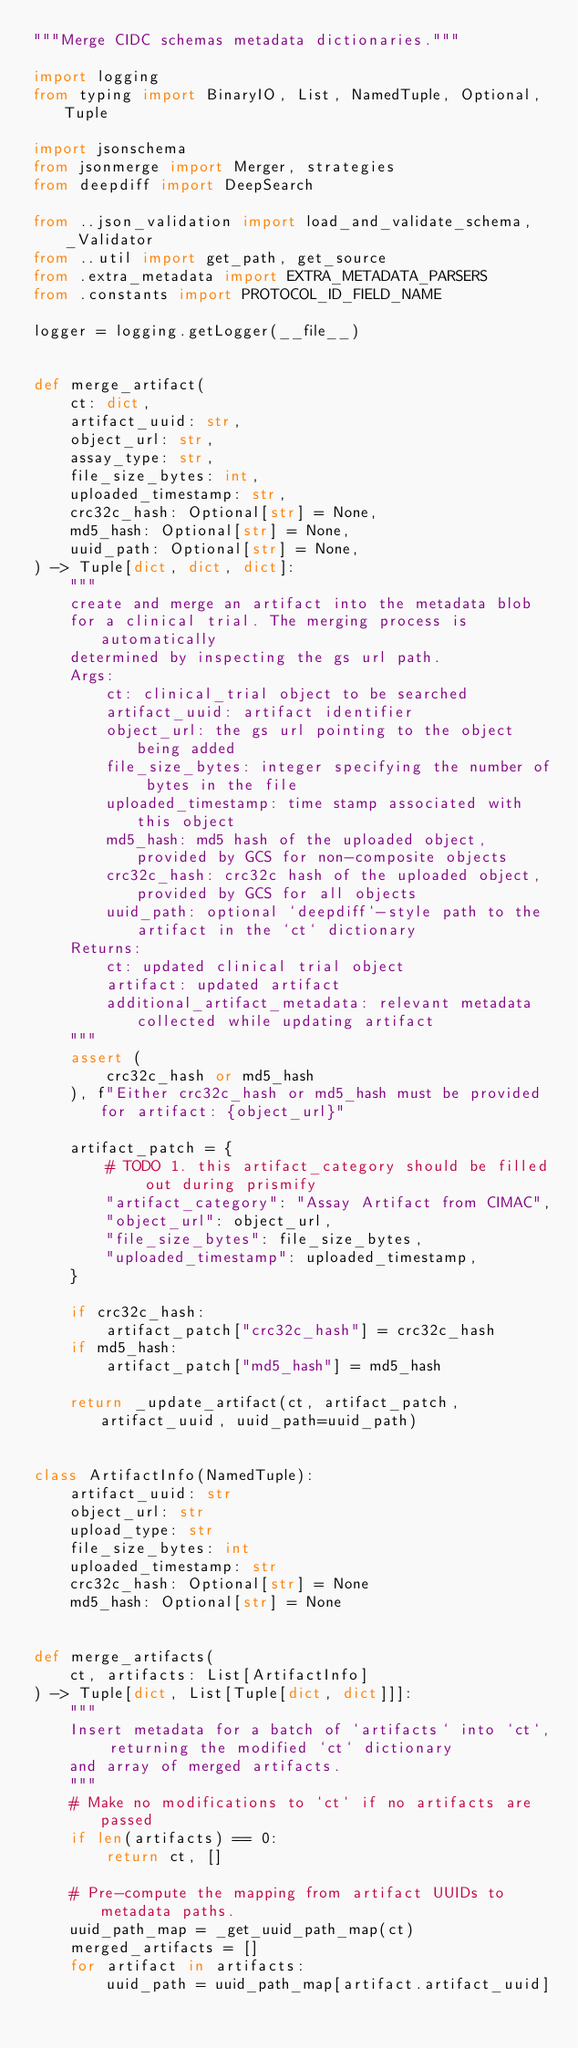<code> <loc_0><loc_0><loc_500><loc_500><_Python_>"""Merge CIDC schemas metadata dictionaries."""

import logging
from typing import BinaryIO, List, NamedTuple, Optional, Tuple

import jsonschema
from jsonmerge import Merger, strategies
from deepdiff import DeepSearch

from ..json_validation import load_and_validate_schema, _Validator
from ..util import get_path, get_source
from .extra_metadata import EXTRA_METADATA_PARSERS
from .constants import PROTOCOL_ID_FIELD_NAME

logger = logging.getLogger(__file__)


def merge_artifact(
    ct: dict,
    artifact_uuid: str,
    object_url: str,
    assay_type: str,
    file_size_bytes: int,
    uploaded_timestamp: str,
    crc32c_hash: Optional[str] = None,
    md5_hash: Optional[str] = None,
    uuid_path: Optional[str] = None,
) -> Tuple[dict, dict, dict]:
    """
    create and merge an artifact into the metadata blob
    for a clinical trial. The merging process is automatically
    determined by inspecting the gs url path.
    Args:
        ct: clinical_trial object to be searched
        artifact_uuid: artifact identifier
        object_url: the gs url pointing to the object being added
        file_size_bytes: integer specifying the number of bytes in the file
        uploaded_timestamp: time stamp associated with this object
        md5_hash: md5 hash of the uploaded object, provided by GCS for non-composite objects
        crc32c_hash: crc32c hash of the uploaded object, provided by GCS for all objects
        uuid_path: optional `deepdiff`-style path to the artifact in the `ct` dictionary
    Returns:
        ct: updated clinical trial object
        artifact: updated artifact
        additional_artifact_metadata: relevant metadata collected while updating artifact
    """
    assert (
        crc32c_hash or md5_hash
    ), f"Either crc32c_hash or md5_hash must be provided for artifact: {object_url}"

    artifact_patch = {
        # TODO 1. this artifact_category should be filled out during prismify
        "artifact_category": "Assay Artifact from CIMAC",
        "object_url": object_url,
        "file_size_bytes": file_size_bytes,
        "uploaded_timestamp": uploaded_timestamp,
    }

    if crc32c_hash:
        artifact_patch["crc32c_hash"] = crc32c_hash
    if md5_hash:
        artifact_patch["md5_hash"] = md5_hash

    return _update_artifact(ct, artifact_patch, artifact_uuid, uuid_path=uuid_path)


class ArtifactInfo(NamedTuple):
    artifact_uuid: str
    object_url: str
    upload_type: str
    file_size_bytes: int
    uploaded_timestamp: str
    crc32c_hash: Optional[str] = None
    md5_hash: Optional[str] = None


def merge_artifacts(
    ct, artifacts: List[ArtifactInfo]
) -> Tuple[dict, List[Tuple[dict, dict]]]:
    """
    Insert metadata for a batch of `artifacts` into `ct`, returning the modified `ct` dictionary
    and array of merged artifacts.
    """
    # Make no modifications to `ct` if no artifacts are passed
    if len(artifacts) == 0:
        return ct, []

    # Pre-compute the mapping from artifact UUIDs to metadata paths.
    uuid_path_map = _get_uuid_path_map(ct)
    merged_artifacts = []
    for artifact in artifacts:
        uuid_path = uuid_path_map[artifact.artifact_uuid]</code> 